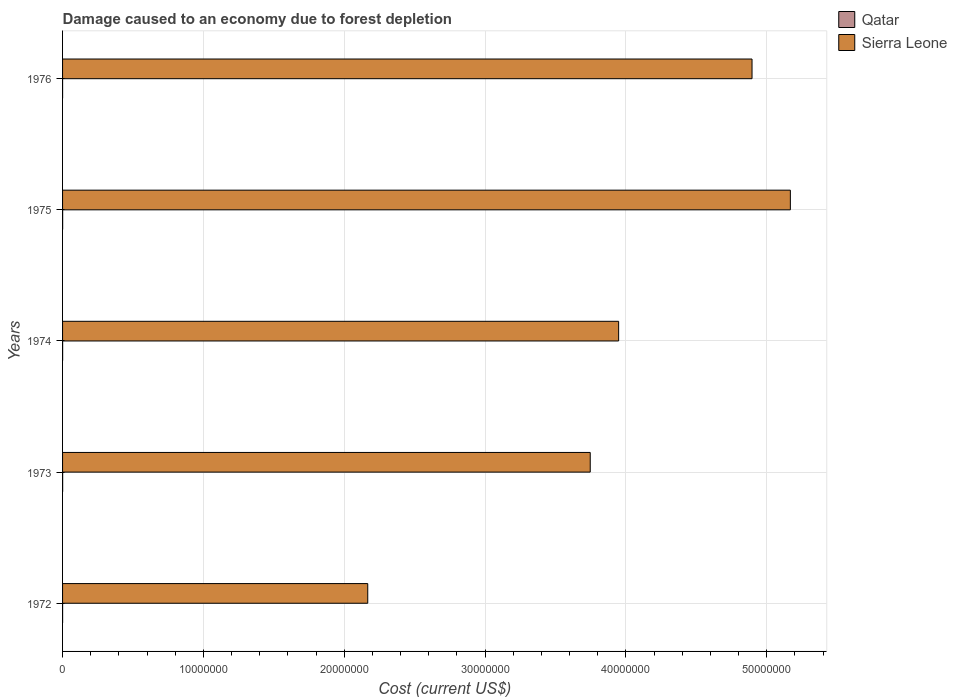How many different coloured bars are there?
Provide a succinct answer. 2. Are the number of bars per tick equal to the number of legend labels?
Provide a short and direct response. Yes. How many bars are there on the 4th tick from the bottom?
Make the answer very short. 2. What is the label of the 2nd group of bars from the top?
Provide a succinct answer. 1975. In how many cases, is the number of bars for a given year not equal to the number of legend labels?
Your answer should be compact. 0. What is the cost of damage caused due to forest depletion in Qatar in 1975?
Ensure brevity in your answer.  5318.55. Across all years, what is the maximum cost of damage caused due to forest depletion in Sierra Leone?
Your answer should be compact. 5.17e+07. Across all years, what is the minimum cost of damage caused due to forest depletion in Qatar?
Provide a succinct answer. 588.31. In which year was the cost of damage caused due to forest depletion in Sierra Leone maximum?
Give a very brief answer. 1975. In which year was the cost of damage caused due to forest depletion in Qatar minimum?
Give a very brief answer. 1976. What is the total cost of damage caused due to forest depletion in Qatar in the graph?
Ensure brevity in your answer.  1.80e+04. What is the difference between the cost of damage caused due to forest depletion in Qatar in 1973 and that in 1975?
Provide a short and direct response. 123.73. What is the difference between the cost of damage caused due to forest depletion in Sierra Leone in 1975 and the cost of damage caused due to forest depletion in Qatar in 1976?
Your answer should be compact. 5.17e+07. What is the average cost of damage caused due to forest depletion in Sierra Leone per year?
Keep it short and to the point. 3.99e+07. In the year 1974, what is the difference between the cost of damage caused due to forest depletion in Qatar and cost of damage caused due to forest depletion in Sierra Leone?
Your answer should be very brief. -3.95e+07. What is the ratio of the cost of damage caused due to forest depletion in Qatar in 1972 to that in 1974?
Give a very brief answer. 0.52. What is the difference between the highest and the second highest cost of damage caused due to forest depletion in Sierra Leone?
Make the answer very short. 2.72e+06. What is the difference between the highest and the lowest cost of damage caused due to forest depletion in Sierra Leone?
Provide a succinct answer. 3.00e+07. In how many years, is the cost of damage caused due to forest depletion in Qatar greater than the average cost of damage caused due to forest depletion in Qatar taken over all years?
Offer a terse response. 3. Is the sum of the cost of damage caused due to forest depletion in Qatar in 1973 and 1975 greater than the maximum cost of damage caused due to forest depletion in Sierra Leone across all years?
Offer a terse response. No. What does the 1st bar from the top in 1975 represents?
Offer a terse response. Sierra Leone. What does the 2nd bar from the bottom in 1972 represents?
Ensure brevity in your answer.  Sierra Leone. How many bars are there?
Give a very brief answer. 10. What is the difference between two consecutive major ticks on the X-axis?
Provide a short and direct response. 1.00e+07. Where does the legend appear in the graph?
Give a very brief answer. Top right. How many legend labels are there?
Make the answer very short. 2. How are the legend labels stacked?
Ensure brevity in your answer.  Vertical. What is the title of the graph?
Keep it short and to the point. Damage caused to an economy due to forest depletion. What is the label or title of the X-axis?
Your answer should be compact. Cost (current US$). What is the Cost (current US$) of Qatar in 1972?
Your answer should be very brief. 2279.57. What is the Cost (current US$) in Sierra Leone in 1972?
Make the answer very short. 2.17e+07. What is the Cost (current US$) in Qatar in 1973?
Provide a short and direct response. 5442.28. What is the Cost (current US$) in Sierra Leone in 1973?
Your answer should be very brief. 3.75e+07. What is the Cost (current US$) in Qatar in 1974?
Keep it short and to the point. 4379.46. What is the Cost (current US$) of Sierra Leone in 1974?
Give a very brief answer. 3.95e+07. What is the Cost (current US$) of Qatar in 1975?
Provide a succinct answer. 5318.55. What is the Cost (current US$) in Sierra Leone in 1975?
Keep it short and to the point. 5.17e+07. What is the Cost (current US$) of Qatar in 1976?
Provide a succinct answer. 588.31. What is the Cost (current US$) of Sierra Leone in 1976?
Provide a short and direct response. 4.90e+07. Across all years, what is the maximum Cost (current US$) of Qatar?
Keep it short and to the point. 5442.28. Across all years, what is the maximum Cost (current US$) in Sierra Leone?
Ensure brevity in your answer.  5.17e+07. Across all years, what is the minimum Cost (current US$) of Qatar?
Give a very brief answer. 588.31. Across all years, what is the minimum Cost (current US$) in Sierra Leone?
Provide a short and direct response. 2.17e+07. What is the total Cost (current US$) in Qatar in the graph?
Provide a short and direct response. 1.80e+04. What is the total Cost (current US$) of Sierra Leone in the graph?
Your answer should be very brief. 1.99e+08. What is the difference between the Cost (current US$) of Qatar in 1972 and that in 1973?
Keep it short and to the point. -3162.71. What is the difference between the Cost (current US$) of Sierra Leone in 1972 and that in 1973?
Provide a short and direct response. -1.58e+07. What is the difference between the Cost (current US$) of Qatar in 1972 and that in 1974?
Provide a short and direct response. -2099.89. What is the difference between the Cost (current US$) of Sierra Leone in 1972 and that in 1974?
Your response must be concise. -1.78e+07. What is the difference between the Cost (current US$) of Qatar in 1972 and that in 1975?
Your answer should be very brief. -3038.98. What is the difference between the Cost (current US$) of Sierra Leone in 1972 and that in 1975?
Keep it short and to the point. -3.00e+07. What is the difference between the Cost (current US$) of Qatar in 1972 and that in 1976?
Your answer should be very brief. 1691.26. What is the difference between the Cost (current US$) in Sierra Leone in 1972 and that in 1976?
Ensure brevity in your answer.  -2.73e+07. What is the difference between the Cost (current US$) of Qatar in 1973 and that in 1974?
Make the answer very short. 1062.81. What is the difference between the Cost (current US$) in Sierra Leone in 1973 and that in 1974?
Your response must be concise. -2.02e+06. What is the difference between the Cost (current US$) of Qatar in 1973 and that in 1975?
Offer a terse response. 123.73. What is the difference between the Cost (current US$) of Sierra Leone in 1973 and that in 1975?
Your response must be concise. -1.42e+07. What is the difference between the Cost (current US$) in Qatar in 1973 and that in 1976?
Offer a terse response. 4853.97. What is the difference between the Cost (current US$) in Sierra Leone in 1973 and that in 1976?
Provide a succinct answer. -1.15e+07. What is the difference between the Cost (current US$) of Qatar in 1974 and that in 1975?
Give a very brief answer. -939.08. What is the difference between the Cost (current US$) of Sierra Leone in 1974 and that in 1975?
Your answer should be compact. -1.22e+07. What is the difference between the Cost (current US$) in Qatar in 1974 and that in 1976?
Provide a succinct answer. 3791.16. What is the difference between the Cost (current US$) in Sierra Leone in 1974 and that in 1976?
Your answer should be very brief. -9.47e+06. What is the difference between the Cost (current US$) of Qatar in 1975 and that in 1976?
Your response must be concise. 4730.24. What is the difference between the Cost (current US$) of Sierra Leone in 1975 and that in 1976?
Give a very brief answer. 2.72e+06. What is the difference between the Cost (current US$) in Qatar in 1972 and the Cost (current US$) in Sierra Leone in 1973?
Give a very brief answer. -3.75e+07. What is the difference between the Cost (current US$) of Qatar in 1972 and the Cost (current US$) of Sierra Leone in 1974?
Your answer should be compact. -3.95e+07. What is the difference between the Cost (current US$) of Qatar in 1972 and the Cost (current US$) of Sierra Leone in 1975?
Provide a short and direct response. -5.17e+07. What is the difference between the Cost (current US$) in Qatar in 1972 and the Cost (current US$) in Sierra Leone in 1976?
Your answer should be very brief. -4.90e+07. What is the difference between the Cost (current US$) in Qatar in 1973 and the Cost (current US$) in Sierra Leone in 1974?
Your answer should be compact. -3.95e+07. What is the difference between the Cost (current US$) in Qatar in 1973 and the Cost (current US$) in Sierra Leone in 1975?
Provide a succinct answer. -5.17e+07. What is the difference between the Cost (current US$) of Qatar in 1973 and the Cost (current US$) of Sierra Leone in 1976?
Give a very brief answer. -4.90e+07. What is the difference between the Cost (current US$) in Qatar in 1974 and the Cost (current US$) in Sierra Leone in 1975?
Your answer should be very brief. -5.17e+07. What is the difference between the Cost (current US$) in Qatar in 1974 and the Cost (current US$) in Sierra Leone in 1976?
Your answer should be compact. -4.90e+07. What is the difference between the Cost (current US$) in Qatar in 1975 and the Cost (current US$) in Sierra Leone in 1976?
Offer a terse response. -4.90e+07. What is the average Cost (current US$) of Qatar per year?
Provide a short and direct response. 3601.63. What is the average Cost (current US$) in Sierra Leone per year?
Make the answer very short. 3.99e+07. In the year 1972, what is the difference between the Cost (current US$) of Qatar and Cost (current US$) of Sierra Leone?
Your answer should be compact. -2.17e+07. In the year 1973, what is the difference between the Cost (current US$) in Qatar and Cost (current US$) in Sierra Leone?
Make the answer very short. -3.75e+07. In the year 1974, what is the difference between the Cost (current US$) in Qatar and Cost (current US$) in Sierra Leone?
Your answer should be very brief. -3.95e+07. In the year 1975, what is the difference between the Cost (current US$) in Qatar and Cost (current US$) in Sierra Leone?
Your answer should be compact. -5.17e+07. In the year 1976, what is the difference between the Cost (current US$) in Qatar and Cost (current US$) in Sierra Leone?
Provide a short and direct response. -4.90e+07. What is the ratio of the Cost (current US$) in Qatar in 1972 to that in 1973?
Your response must be concise. 0.42. What is the ratio of the Cost (current US$) of Sierra Leone in 1972 to that in 1973?
Keep it short and to the point. 0.58. What is the ratio of the Cost (current US$) of Qatar in 1972 to that in 1974?
Offer a very short reply. 0.52. What is the ratio of the Cost (current US$) of Sierra Leone in 1972 to that in 1974?
Give a very brief answer. 0.55. What is the ratio of the Cost (current US$) of Qatar in 1972 to that in 1975?
Your answer should be very brief. 0.43. What is the ratio of the Cost (current US$) of Sierra Leone in 1972 to that in 1975?
Offer a very short reply. 0.42. What is the ratio of the Cost (current US$) in Qatar in 1972 to that in 1976?
Keep it short and to the point. 3.87. What is the ratio of the Cost (current US$) of Sierra Leone in 1972 to that in 1976?
Your answer should be compact. 0.44. What is the ratio of the Cost (current US$) of Qatar in 1973 to that in 1974?
Offer a terse response. 1.24. What is the ratio of the Cost (current US$) of Sierra Leone in 1973 to that in 1974?
Your answer should be compact. 0.95. What is the ratio of the Cost (current US$) in Qatar in 1973 to that in 1975?
Offer a terse response. 1.02. What is the ratio of the Cost (current US$) of Sierra Leone in 1973 to that in 1975?
Make the answer very short. 0.72. What is the ratio of the Cost (current US$) in Qatar in 1973 to that in 1976?
Provide a short and direct response. 9.25. What is the ratio of the Cost (current US$) in Sierra Leone in 1973 to that in 1976?
Give a very brief answer. 0.77. What is the ratio of the Cost (current US$) in Qatar in 1974 to that in 1975?
Provide a short and direct response. 0.82. What is the ratio of the Cost (current US$) in Sierra Leone in 1974 to that in 1975?
Your answer should be compact. 0.76. What is the ratio of the Cost (current US$) of Qatar in 1974 to that in 1976?
Give a very brief answer. 7.44. What is the ratio of the Cost (current US$) in Sierra Leone in 1974 to that in 1976?
Your answer should be compact. 0.81. What is the ratio of the Cost (current US$) of Qatar in 1975 to that in 1976?
Your answer should be very brief. 9.04. What is the ratio of the Cost (current US$) in Sierra Leone in 1975 to that in 1976?
Offer a very short reply. 1.06. What is the difference between the highest and the second highest Cost (current US$) in Qatar?
Offer a terse response. 123.73. What is the difference between the highest and the second highest Cost (current US$) of Sierra Leone?
Make the answer very short. 2.72e+06. What is the difference between the highest and the lowest Cost (current US$) of Qatar?
Provide a succinct answer. 4853.97. What is the difference between the highest and the lowest Cost (current US$) of Sierra Leone?
Ensure brevity in your answer.  3.00e+07. 